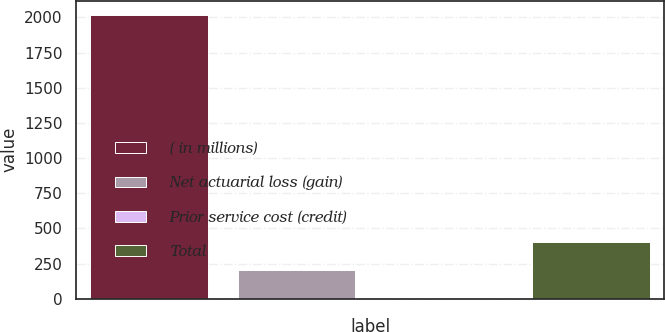Convert chart. <chart><loc_0><loc_0><loc_500><loc_500><bar_chart><fcel>( in millions)<fcel>Net actuarial loss (gain)<fcel>Prior service cost (credit)<fcel>Total<nl><fcel>2018<fcel>203.33<fcel>1.7<fcel>404.96<nl></chart> 